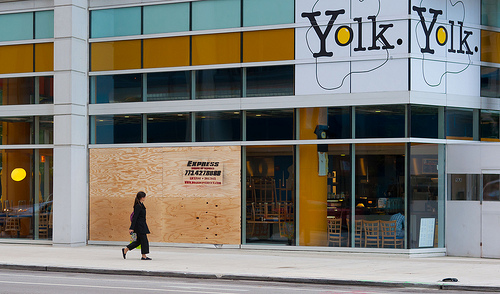<image>
Can you confirm if the woman is under the building? No. The woman is not positioned under the building. The vertical relationship between these objects is different. Where is the girl in relation to the wall? Is it on the wall? No. The girl is not positioned on the wall. They may be near each other, but the girl is not supported by or resting on top of the wall. 